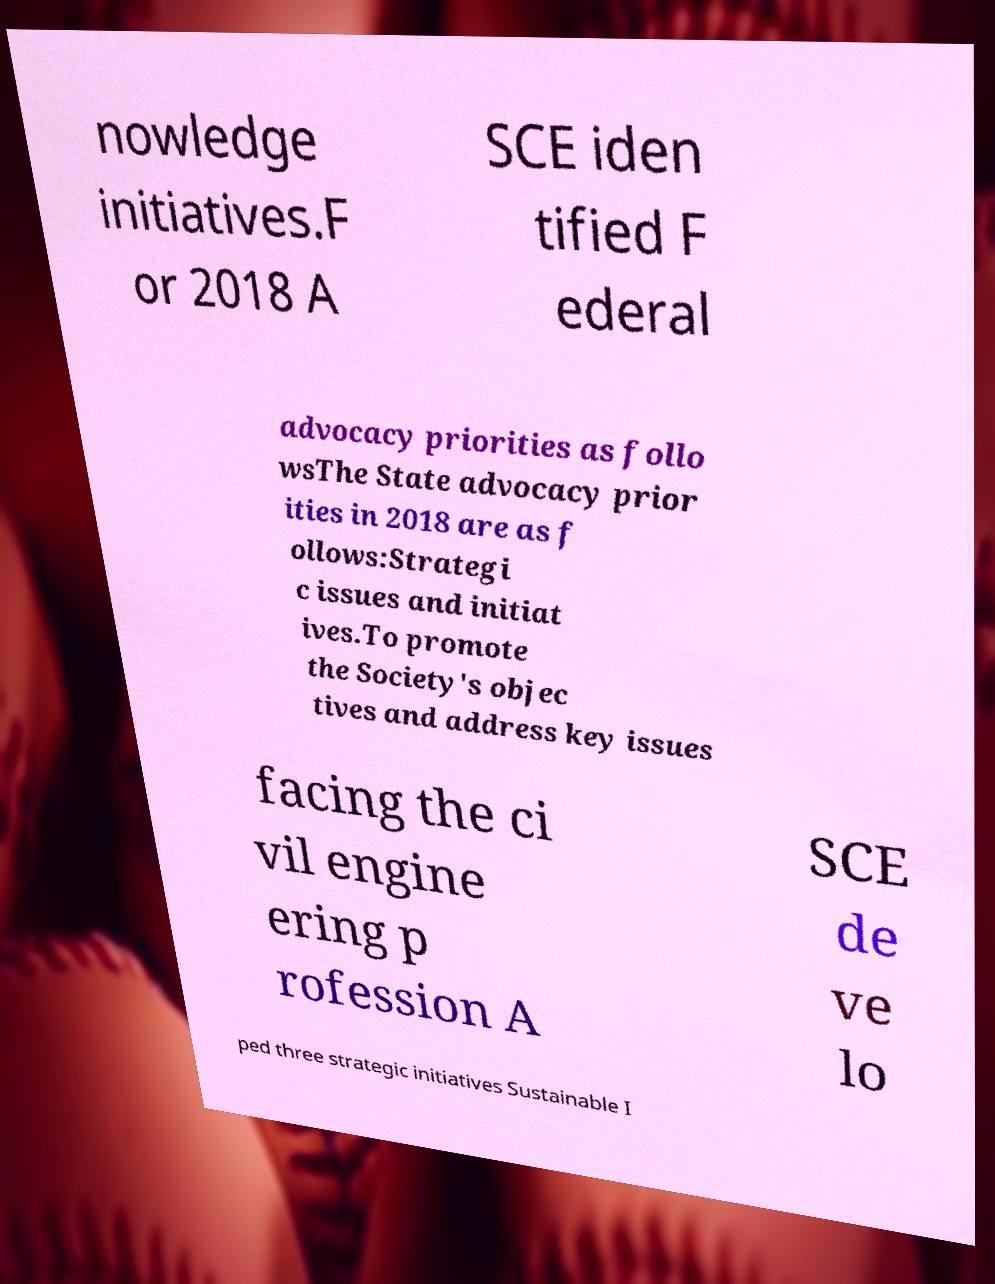Can you accurately transcribe the text from the provided image for me? nowledge initiatives.F or 2018 A SCE iden tified F ederal advocacy priorities as follo wsThe State advocacy prior ities in 2018 are as f ollows:Strategi c issues and initiat ives.To promote the Society's objec tives and address key issues facing the ci vil engine ering p rofession A SCE de ve lo ped three strategic initiatives Sustainable I 